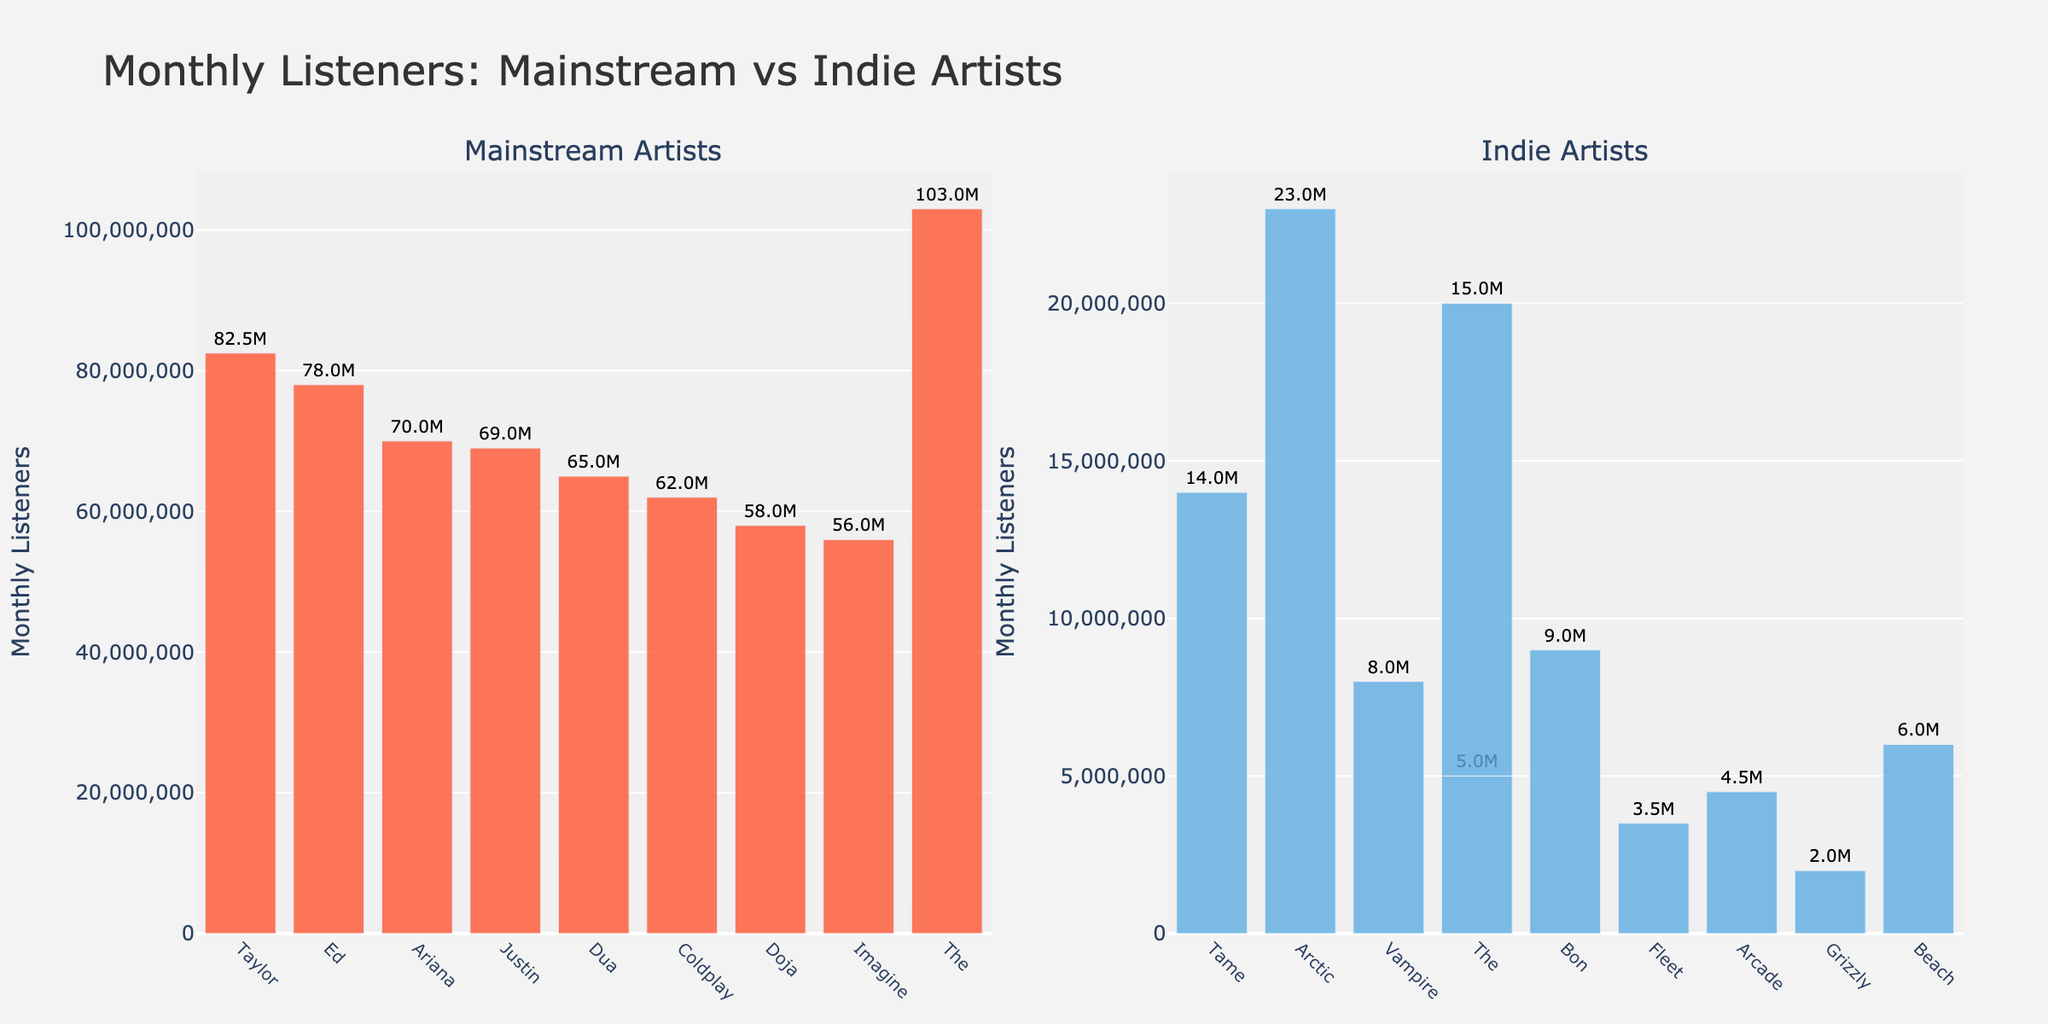Which mainstream artist has the most monthly listeners? Taylor Swift has the highest monthly listeners among the mainstream artists shown. The bar for Taylor Swift is the tallest in the "Mainstream Artists" section, indicating she has the highest count.
Answer: Taylor Swift Compare the monthly listeners of The Weeknd to that of Ed Sheeran. Which one has more? The Weeknd has more monthly listeners than Ed Sheeran. The bar for The Weeknd is significantly taller and shows 103 million, compared to Ed Sheeran's 78 million monthly listeners.
Answer: The Weeknd What's the total sum of monthly listeners for all indie artists? Summing the monthly listeners for all indie artists: 14M (Tame Impala) + 23M (Arctic Monkeys) + 8M (Vampire Weekend) + 5M (The National) + 9M (Bon Iver) + 3.5M (Fleet Foxes) + 4.5M (Arcade Fire) + 2M (Grizzly Bear) + 6M (Beach House) + 15M (The Strokes) = 90 million.
Answer: 90 million Which segment has the artist with the lowest monthly listeners, mainstream or indie? Indie artists have the lowest monthly listeners. Grizzly Bear, an indie artist, has the lowest value at 2 million, which is lower than the least in the mainstream category.
Answer: Indie How many more monthly listeners does Taylor Swift have compared to Tame Impala? Taylor Swift has 82.5 million monthly listeners, and Tame Impala has 14 million. The difference is 82.5M - 14M = 68.5 million.
Answer: 68.5 million What's the average number of monthly listeners for mainstream artists? Adding the monthly listeners for mainstream artists: 82.5M (Taylor Swift) + 78M (Ed Sheeran) + 70M (Ariana Grande) + 69M (Justin Bieber) + 65M (Dua Lipa) + 62M (Coldplay) + 58M (Doja Cat) + 56M (Imagine Dragons) + 103M (The Weeknd) = 643.5 million. Dividing by the number of artists (9): 643.5M / 9 ≈ 71.5 million.
Answer: 71.5 million Which artist in the indie category has the highest monthly listeners? Arctic Monkeys has the highest monthly listeners among indie artists, with a bar indicating 23 million.
Answer: Arctic Monkeys Is the combined number of listeners for Grizzly Bear, Beach House, and The National greater than the total listeners of Doja Cat? Grizzly Bear (2M) + Beach House (6M) + The National (5M) = 13 million, which is less than Doja Cat's 58 million.
Answer: No Which artist has almost double the monthly listeners of Dua Lipa? The Weeknd has 103 million monthly listeners, which is almost double Dua Lipa's 65 million.
Answer: The Weeknd By how much do Justin Bieber's monthly listeners exceed those of Bon Iver? Justin Bieber has 69 million monthly listeners, and Bon Iver has 9 million. The difference is 69M - 9M = 60 million.
Answer: 60 million 